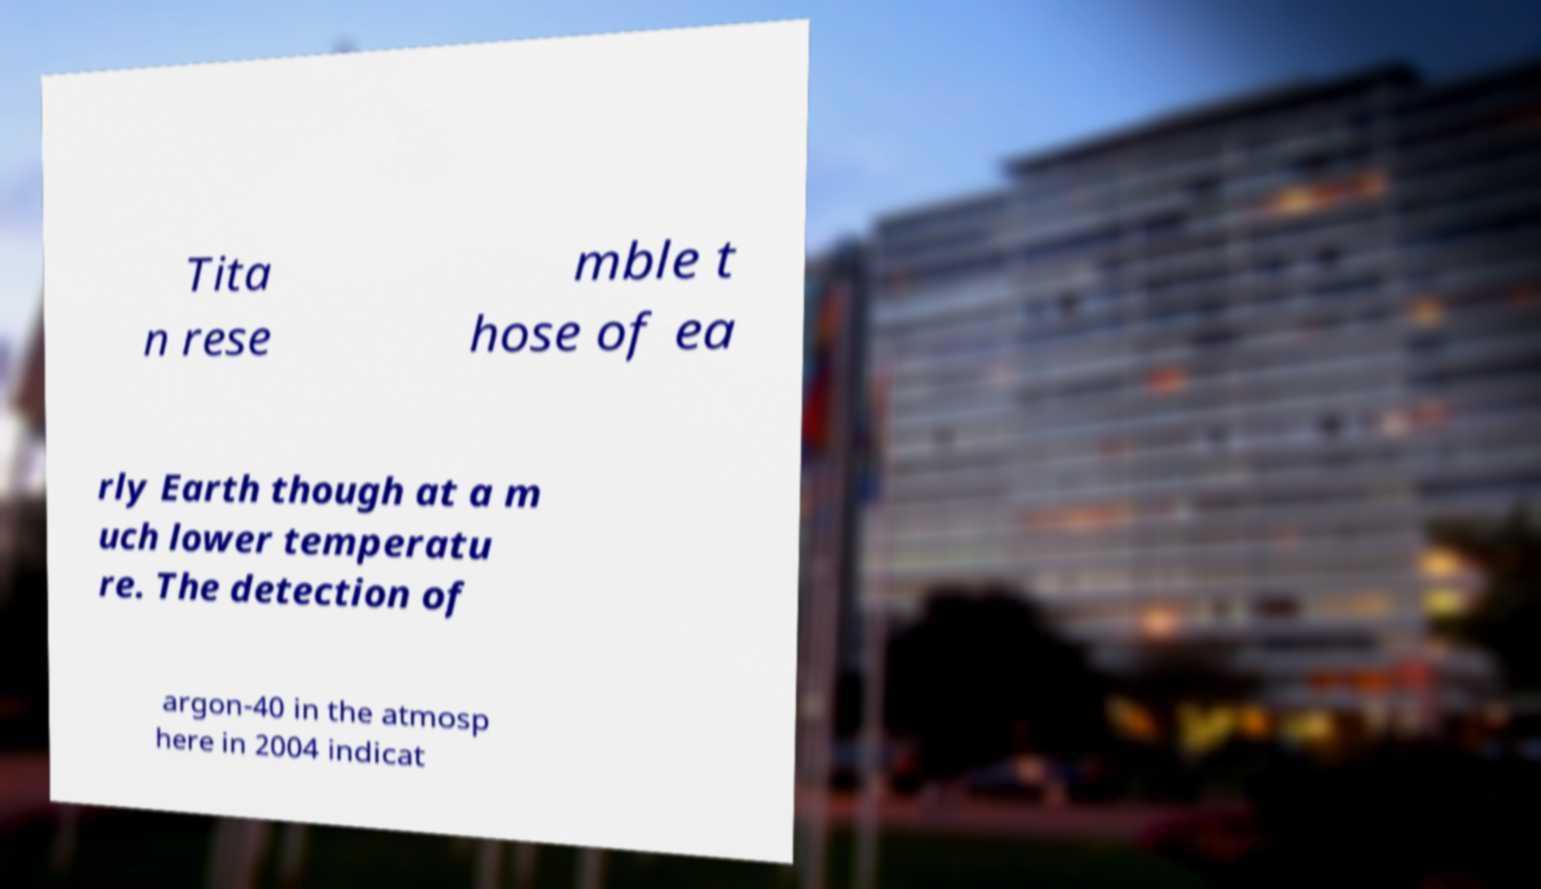I need the written content from this picture converted into text. Can you do that? Tita n rese mble t hose of ea rly Earth though at a m uch lower temperatu re. The detection of argon-40 in the atmosp here in 2004 indicat 